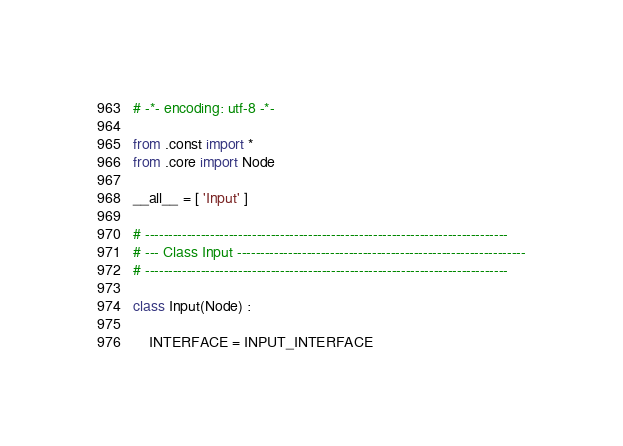Convert code to text. <code><loc_0><loc_0><loc_500><loc_500><_Python_># -*- encoding: utf-8 -*-

from .const import *
from .core import Node

__all__ = [ 'Input' ]

# ------------------------------------------------------------------------------
# --- Class Input --------------------------------------------------------------
# ------------------------------------------------------------------------------

class Input(Node) :

    INTERFACE = INPUT_INTERFACE

</code> 